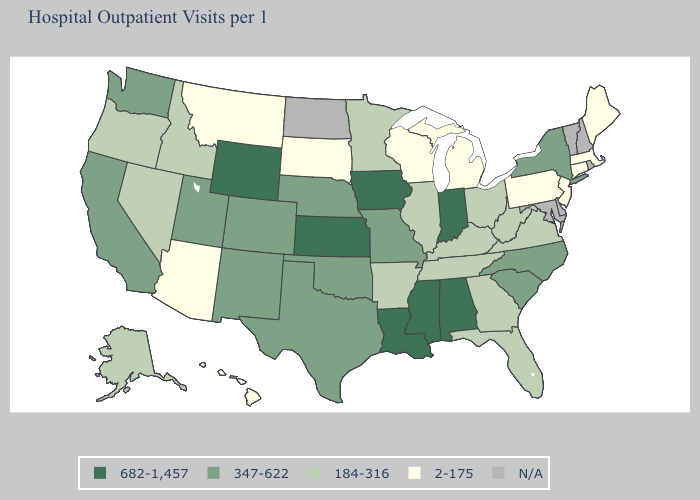What is the value of Tennessee?
Give a very brief answer. 184-316. Does Arizona have the lowest value in the West?
Quick response, please. Yes. Among the states that border Texas , which have the lowest value?
Give a very brief answer. Arkansas. What is the value of New Mexico?
Give a very brief answer. 347-622. Which states have the highest value in the USA?
Write a very short answer. Alabama, Indiana, Iowa, Kansas, Louisiana, Mississippi, Wyoming. Among the states that border Tennessee , does Kentucky have the lowest value?
Quick response, please. Yes. Name the states that have a value in the range 184-316?
Concise answer only. Alaska, Arkansas, Florida, Georgia, Idaho, Illinois, Kentucky, Minnesota, Nevada, Ohio, Oregon, Tennessee, Virginia, West Virginia. Which states have the lowest value in the MidWest?
Quick response, please. Michigan, South Dakota, Wisconsin. Does Kansas have the highest value in the USA?
Concise answer only. Yes. What is the value of Kansas?
Short answer required. 682-1,457. Among the states that border Louisiana , does Mississippi have the highest value?
Quick response, please. Yes. Among the states that border Texas , does New Mexico have the lowest value?
Short answer required. No. Name the states that have a value in the range 347-622?
Concise answer only. California, Colorado, Missouri, Nebraska, New Mexico, New York, North Carolina, Oklahoma, South Carolina, Texas, Utah, Washington. Name the states that have a value in the range 184-316?
Give a very brief answer. Alaska, Arkansas, Florida, Georgia, Idaho, Illinois, Kentucky, Minnesota, Nevada, Ohio, Oregon, Tennessee, Virginia, West Virginia. Is the legend a continuous bar?
Concise answer only. No. 